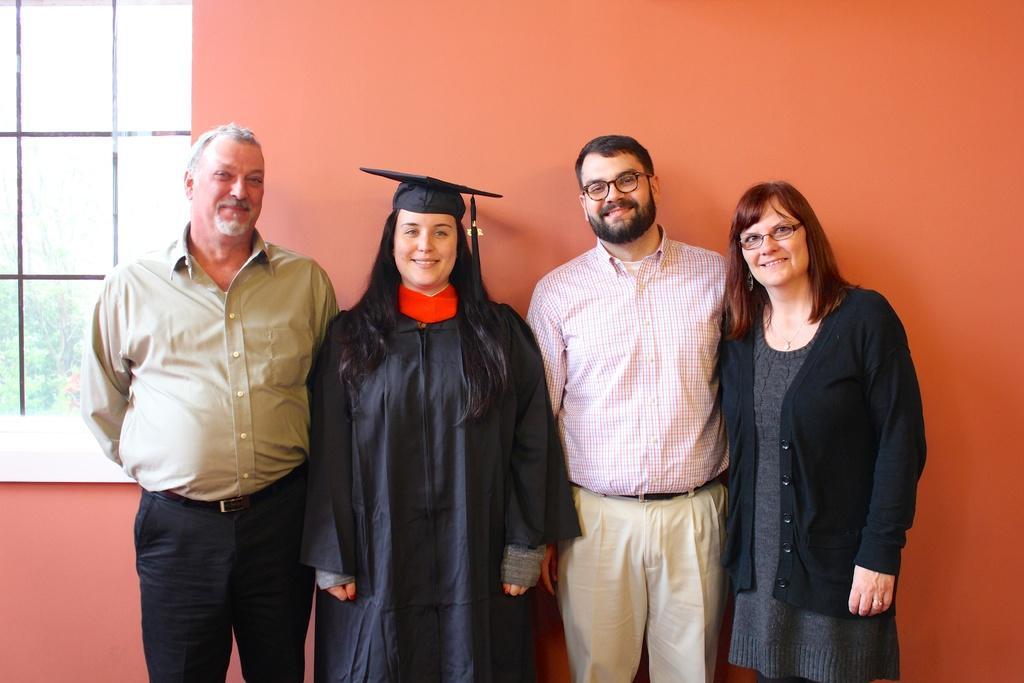Could you give a brief overview of what you see in this image? In this image there are persons standing in the center and smiling. In the background there is a wall there is a window. 